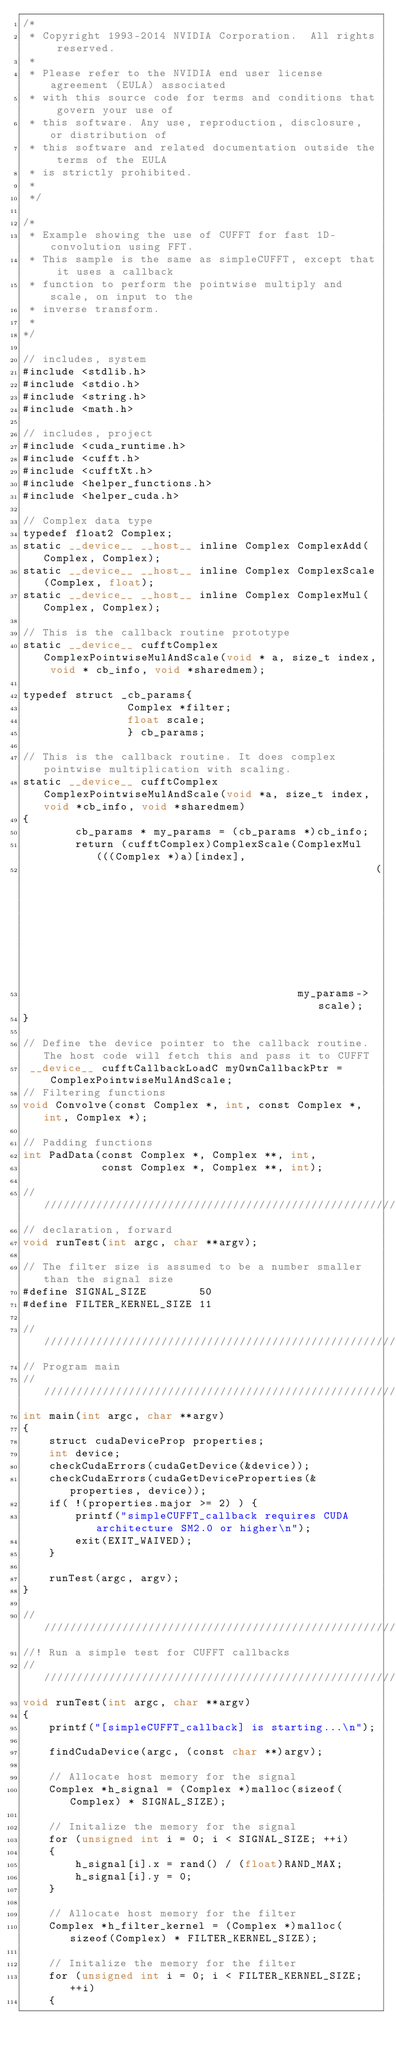<code> <loc_0><loc_0><loc_500><loc_500><_Cuda_>/*
 * Copyright 1993-2014 NVIDIA Corporation.  All rights reserved.
 *
 * Please refer to the NVIDIA end user license agreement (EULA) associated
 * with this source code for terms and conditions that govern your use of
 * this software. Any use, reproduction, disclosure, or distribution of
 * this software and related documentation outside the terms of the EULA
 * is strictly prohibited.
 *
 */

/* 
 * Example showing the use of CUFFT for fast 1D-convolution using FFT. 
 * This sample is the same as simpleCUFFT, except that it uses a callback
 * function to perform the pointwise multiply and scale, on input to the
 * inverse transform.
 * 
*/

// includes, system
#include <stdlib.h>
#include <stdio.h>
#include <string.h>
#include <math.h>

// includes, project
#include <cuda_runtime.h>
#include <cufft.h>
#include <cufftXt.h>
#include <helper_functions.h>
#include <helper_cuda.h>

// Complex data type
typedef float2 Complex;
static __device__ __host__ inline Complex ComplexAdd(Complex, Complex);
static __device__ __host__ inline Complex ComplexScale(Complex, float);
static __device__ __host__ inline Complex ComplexMul(Complex, Complex);

// This is the callback routine prototype
static __device__ cufftComplex ComplexPointwiseMulAndScale(void * a, size_t index, void * cb_info, void *sharedmem);

typedef struct _cb_params{
                Complex *filter;
                float scale;
                } cb_params;

// This is the callback routine. It does complex pointwise multiplication with scaling.
static __device__ cufftComplex ComplexPointwiseMulAndScale(void *a, size_t index, void *cb_info, void *sharedmem)
{
        cb_params * my_params = (cb_params *)cb_info;
        return (cufftComplex)ComplexScale(ComplexMul(((Complex *)a)[index], 
                                                      (my_params->filter)[index]), 
                                          my_params->scale);
}

// Define the device pointer to the callback routine. The host code will fetch this and pass it to CUFFT
 __device__ cufftCallbackLoadC myOwnCallbackPtr = ComplexPointwiseMulAndScale; 
// Filtering functions
void Convolve(const Complex *, int, const Complex *, int, Complex *);

// Padding functions
int PadData(const Complex *, Complex **, int,
            const Complex *, Complex **, int);

////////////////////////////////////////////////////////////////////////////////
// declaration, forward
void runTest(int argc, char **argv);

// The filter size is assumed to be a number smaller than the signal size
#define SIGNAL_SIZE        50
#define FILTER_KERNEL_SIZE 11

////////////////////////////////////////////////////////////////////////////////
// Program main
////////////////////////////////////////////////////////////////////////////////
int main(int argc, char **argv)
{
    struct cudaDeviceProp properties;
    int device;
    checkCudaErrors(cudaGetDevice(&device));
    checkCudaErrors(cudaGetDeviceProperties(&properties, device));
    if( !(properties.major >= 2) ) {
        printf("simpleCUFFT_callback requires CUDA architecture SM2.0 or higher\n");
        exit(EXIT_WAIVED);
    }

    runTest(argc, argv);
}

////////////////////////////////////////////////////////////////////////////////
//! Run a simple test for CUFFT callbacks
////////////////////////////////////////////////////////////////////////////////
void runTest(int argc, char **argv)
{
    printf("[simpleCUFFT_callback] is starting...\n");

    findCudaDevice(argc, (const char **)argv);

    // Allocate host memory for the signal
    Complex *h_signal = (Complex *)malloc(sizeof(Complex) * SIGNAL_SIZE);

    // Initalize the memory for the signal
    for (unsigned int i = 0; i < SIGNAL_SIZE; ++i)
    {
        h_signal[i].x = rand() / (float)RAND_MAX;
        h_signal[i].y = 0;
    }

    // Allocate host memory for the filter
    Complex *h_filter_kernel = (Complex *)malloc(sizeof(Complex) * FILTER_KERNEL_SIZE);

    // Initalize the memory for the filter
    for (unsigned int i = 0; i < FILTER_KERNEL_SIZE; ++i)
    {</code> 